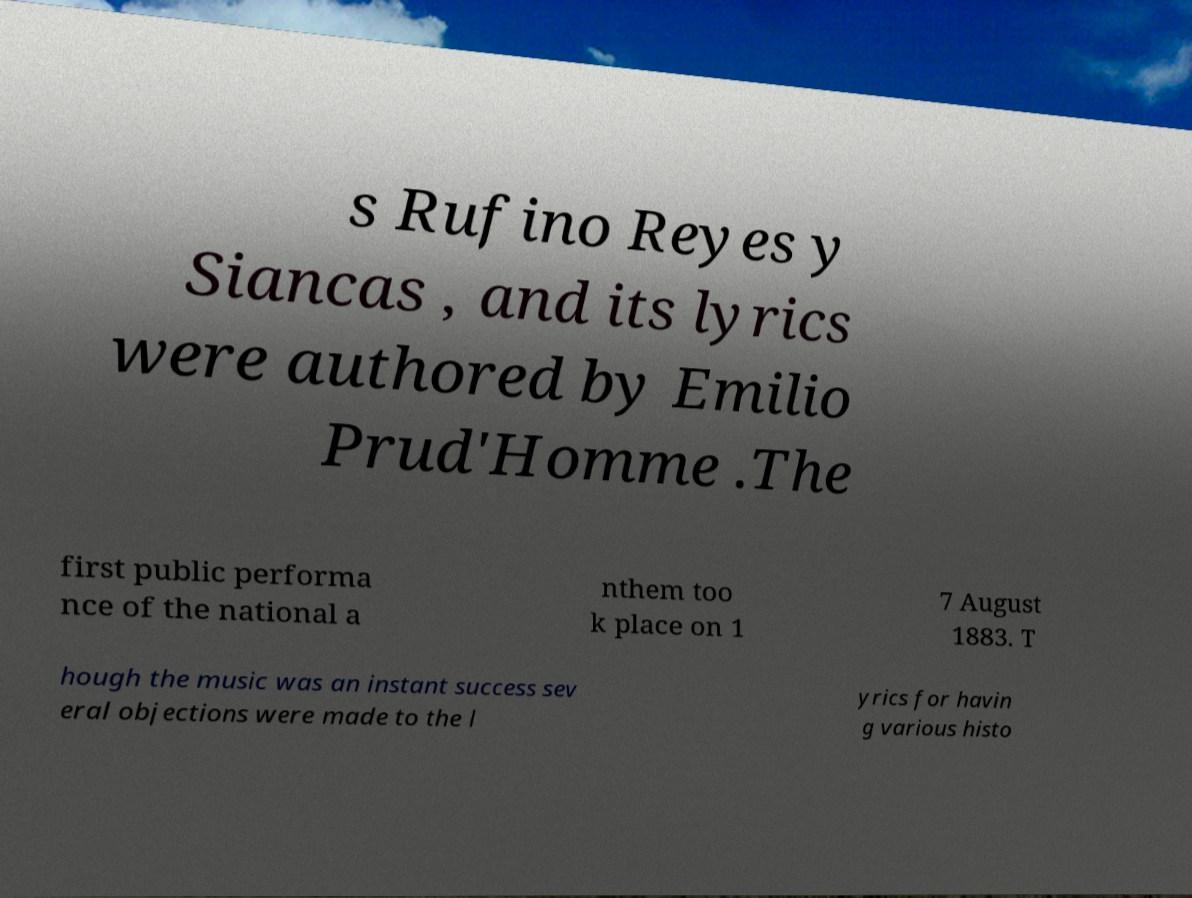Please read and relay the text visible in this image. What does it say? s Rufino Reyes y Siancas , and its lyrics were authored by Emilio Prud'Homme .The first public performa nce of the national a nthem too k place on 1 7 August 1883. T hough the music was an instant success sev eral objections were made to the l yrics for havin g various histo 